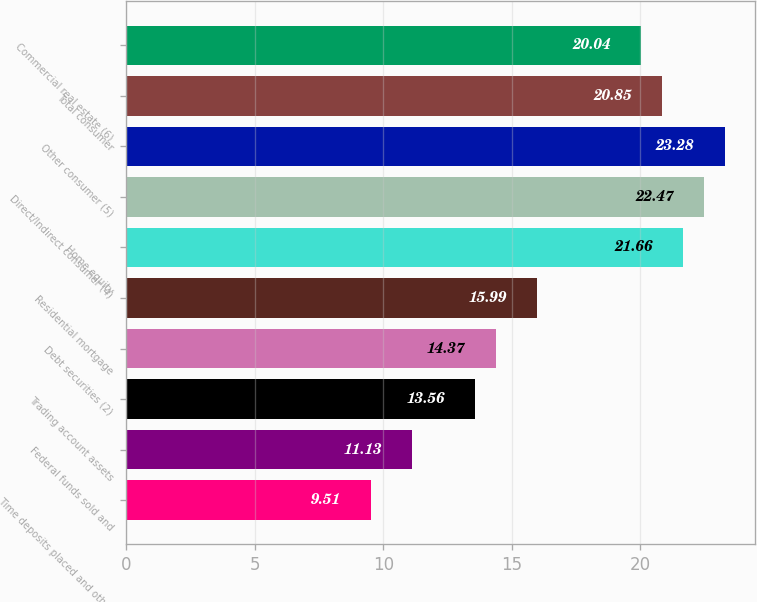Convert chart to OTSL. <chart><loc_0><loc_0><loc_500><loc_500><bar_chart><fcel>Time deposits placed and other<fcel>Federal funds sold and<fcel>Trading account assets<fcel>Debt securities (2)<fcel>Residential mortgage<fcel>Home equity<fcel>Direct/Indirect consumer (4)<fcel>Other consumer (5)<fcel>Total consumer<fcel>Commercial real estate (6)<nl><fcel>9.51<fcel>11.13<fcel>13.56<fcel>14.37<fcel>15.99<fcel>21.66<fcel>22.47<fcel>23.28<fcel>20.85<fcel>20.04<nl></chart> 